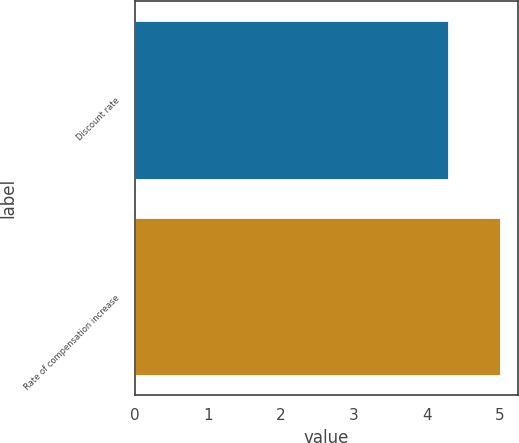<chart> <loc_0><loc_0><loc_500><loc_500><bar_chart><fcel>Discount rate<fcel>Rate of compensation increase<nl><fcel>4.3<fcel>5<nl></chart> 